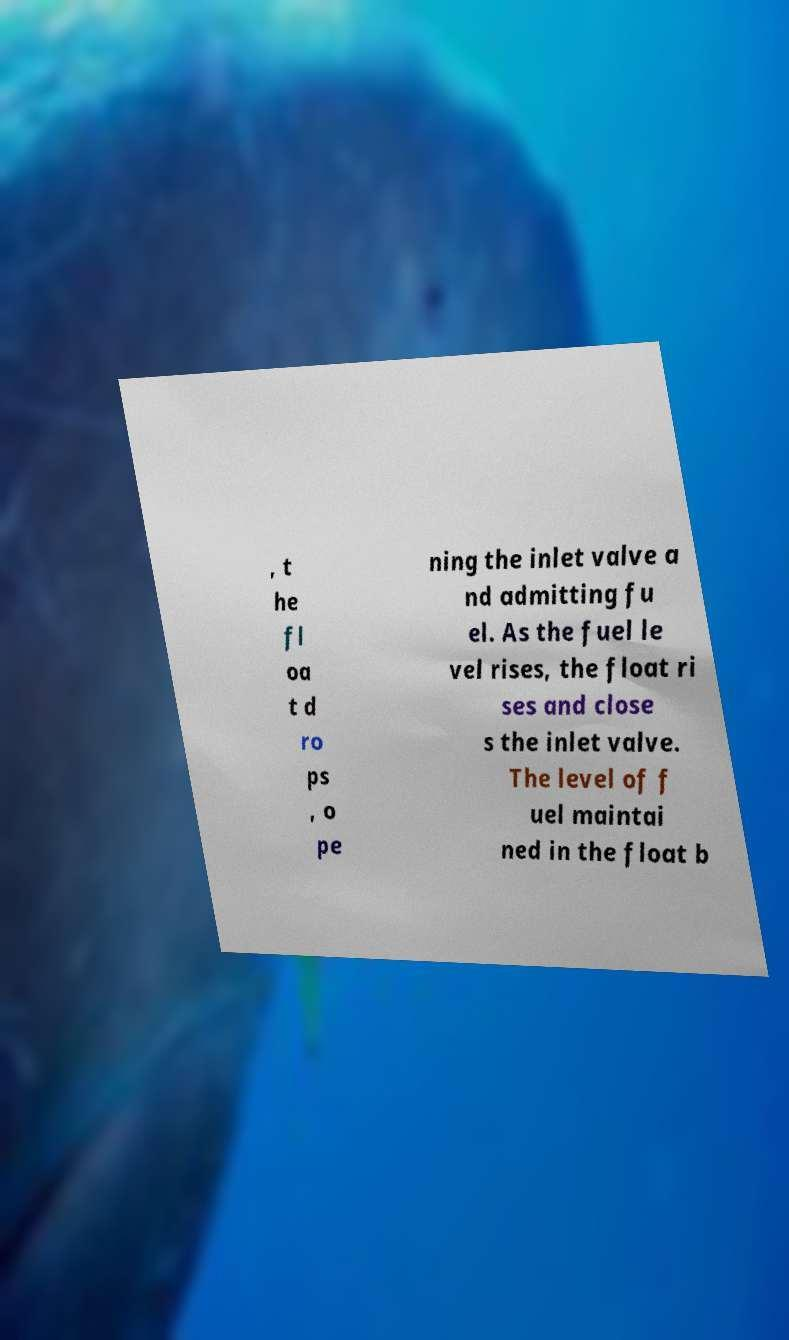Please identify and transcribe the text found in this image. , t he fl oa t d ro ps , o pe ning the inlet valve a nd admitting fu el. As the fuel le vel rises, the float ri ses and close s the inlet valve. The level of f uel maintai ned in the float b 